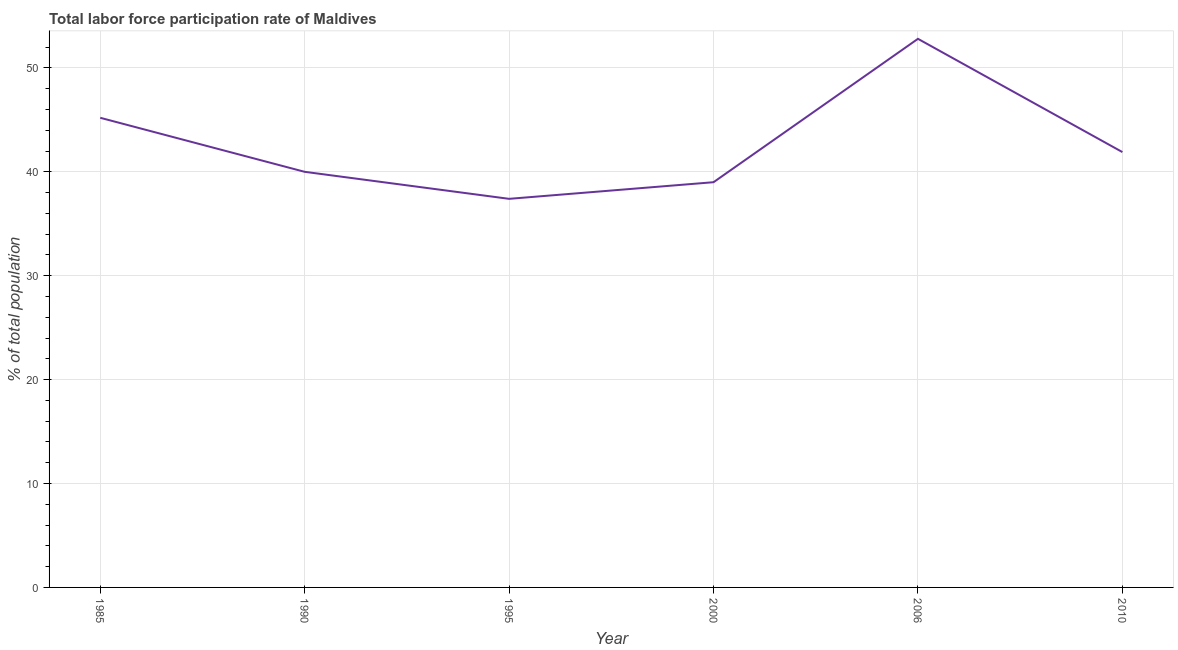What is the total labor force participation rate in 2006?
Your answer should be compact. 52.8. Across all years, what is the maximum total labor force participation rate?
Give a very brief answer. 52.8. Across all years, what is the minimum total labor force participation rate?
Your answer should be compact. 37.4. What is the sum of the total labor force participation rate?
Your response must be concise. 256.3. What is the difference between the total labor force participation rate in 1995 and 2000?
Your response must be concise. -1.6. What is the average total labor force participation rate per year?
Provide a succinct answer. 42.72. What is the median total labor force participation rate?
Offer a very short reply. 40.95. In how many years, is the total labor force participation rate greater than 12 %?
Make the answer very short. 6. Do a majority of the years between 1995 and 1985 (inclusive) have total labor force participation rate greater than 42 %?
Provide a short and direct response. No. What is the ratio of the total labor force participation rate in 1995 to that in 2006?
Offer a terse response. 0.71. Is the total labor force participation rate in 1990 less than that in 2000?
Give a very brief answer. No. Is the difference between the total labor force participation rate in 1990 and 1995 greater than the difference between any two years?
Keep it short and to the point. No. What is the difference between the highest and the second highest total labor force participation rate?
Offer a terse response. 7.6. Is the sum of the total labor force participation rate in 1990 and 1995 greater than the maximum total labor force participation rate across all years?
Make the answer very short. Yes. What is the difference between the highest and the lowest total labor force participation rate?
Your answer should be compact. 15.4. How many lines are there?
Keep it short and to the point. 1. How many years are there in the graph?
Your answer should be very brief. 6. Does the graph contain any zero values?
Provide a short and direct response. No. Does the graph contain grids?
Provide a succinct answer. Yes. What is the title of the graph?
Provide a succinct answer. Total labor force participation rate of Maldives. What is the label or title of the X-axis?
Make the answer very short. Year. What is the label or title of the Y-axis?
Your answer should be very brief. % of total population. What is the % of total population of 1985?
Give a very brief answer. 45.2. What is the % of total population in 1995?
Offer a terse response. 37.4. What is the % of total population in 2006?
Give a very brief answer. 52.8. What is the % of total population in 2010?
Offer a terse response. 41.9. What is the difference between the % of total population in 1985 and 1990?
Offer a very short reply. 5.2. What is the difference between the % of total population in 1985 and 2000?
Your response must be concise. 6.2. What is the difference between the % of total population in 1990 and 1995?
Provide a short and direct response. 2.6. What is the difference between the % of total population in 1995 and 2000?
Keep it short and to the point. -1.6. What is the difference between the % of total population in 1995 and 2006?
Make the answer very short. -15.4. What is the difference between the % of total population in 2000 and 2006?
Make the answer very short. -13.8. What is the difference between the % of total population in 2000 and 2010?
Make the answer very short. -2.9. What is the difference between the % of total population in 2006 and 2010?
Your answer should be very brief. 10.9. What is the ratio of the % of total population in 1985 to that in 1990?
Provide a succinct answer. 1.13. What is the ratio of the % of total population in 1985 to that in 1995?
Offer a terse response. 1.21. What is the ratio of the % of total population in 1985 to that in 2000?
Provide a succinct answer. 1.16. What is the ratio of the % of total population in 1985 to that in 2006?
Your response must be concise. 0.86. What is the ratio of the % of total population in 1985 to that in 2010?
Offer a very short reply. 1.08. What is the ratio of the % of total population in 1990 to that in 1995?
Your response must be concise. 1.07. What is the ratio of the % of total population in 1990 to that in 2006?
Your answer should be very brief. 0.76. What is the ratio of the % of total population in 1990 to that in 2010?
Provide a short and direct response. 0.95. What is the ratio of the % of total population in 1995 to that in 2006?
Your answer should be very brief. 0.71. What is the ratio of the % of total population in 1995 to that in 2010?
Your answer should be compact. 0.89. What is the ratio of the % of total population in 2000 to that in 2006?
Ensure brevity in your answer.  0.74. What is the ratio of the % of total population in 2006 to that in 2010?
Keep it short and to the point. 1.26. 